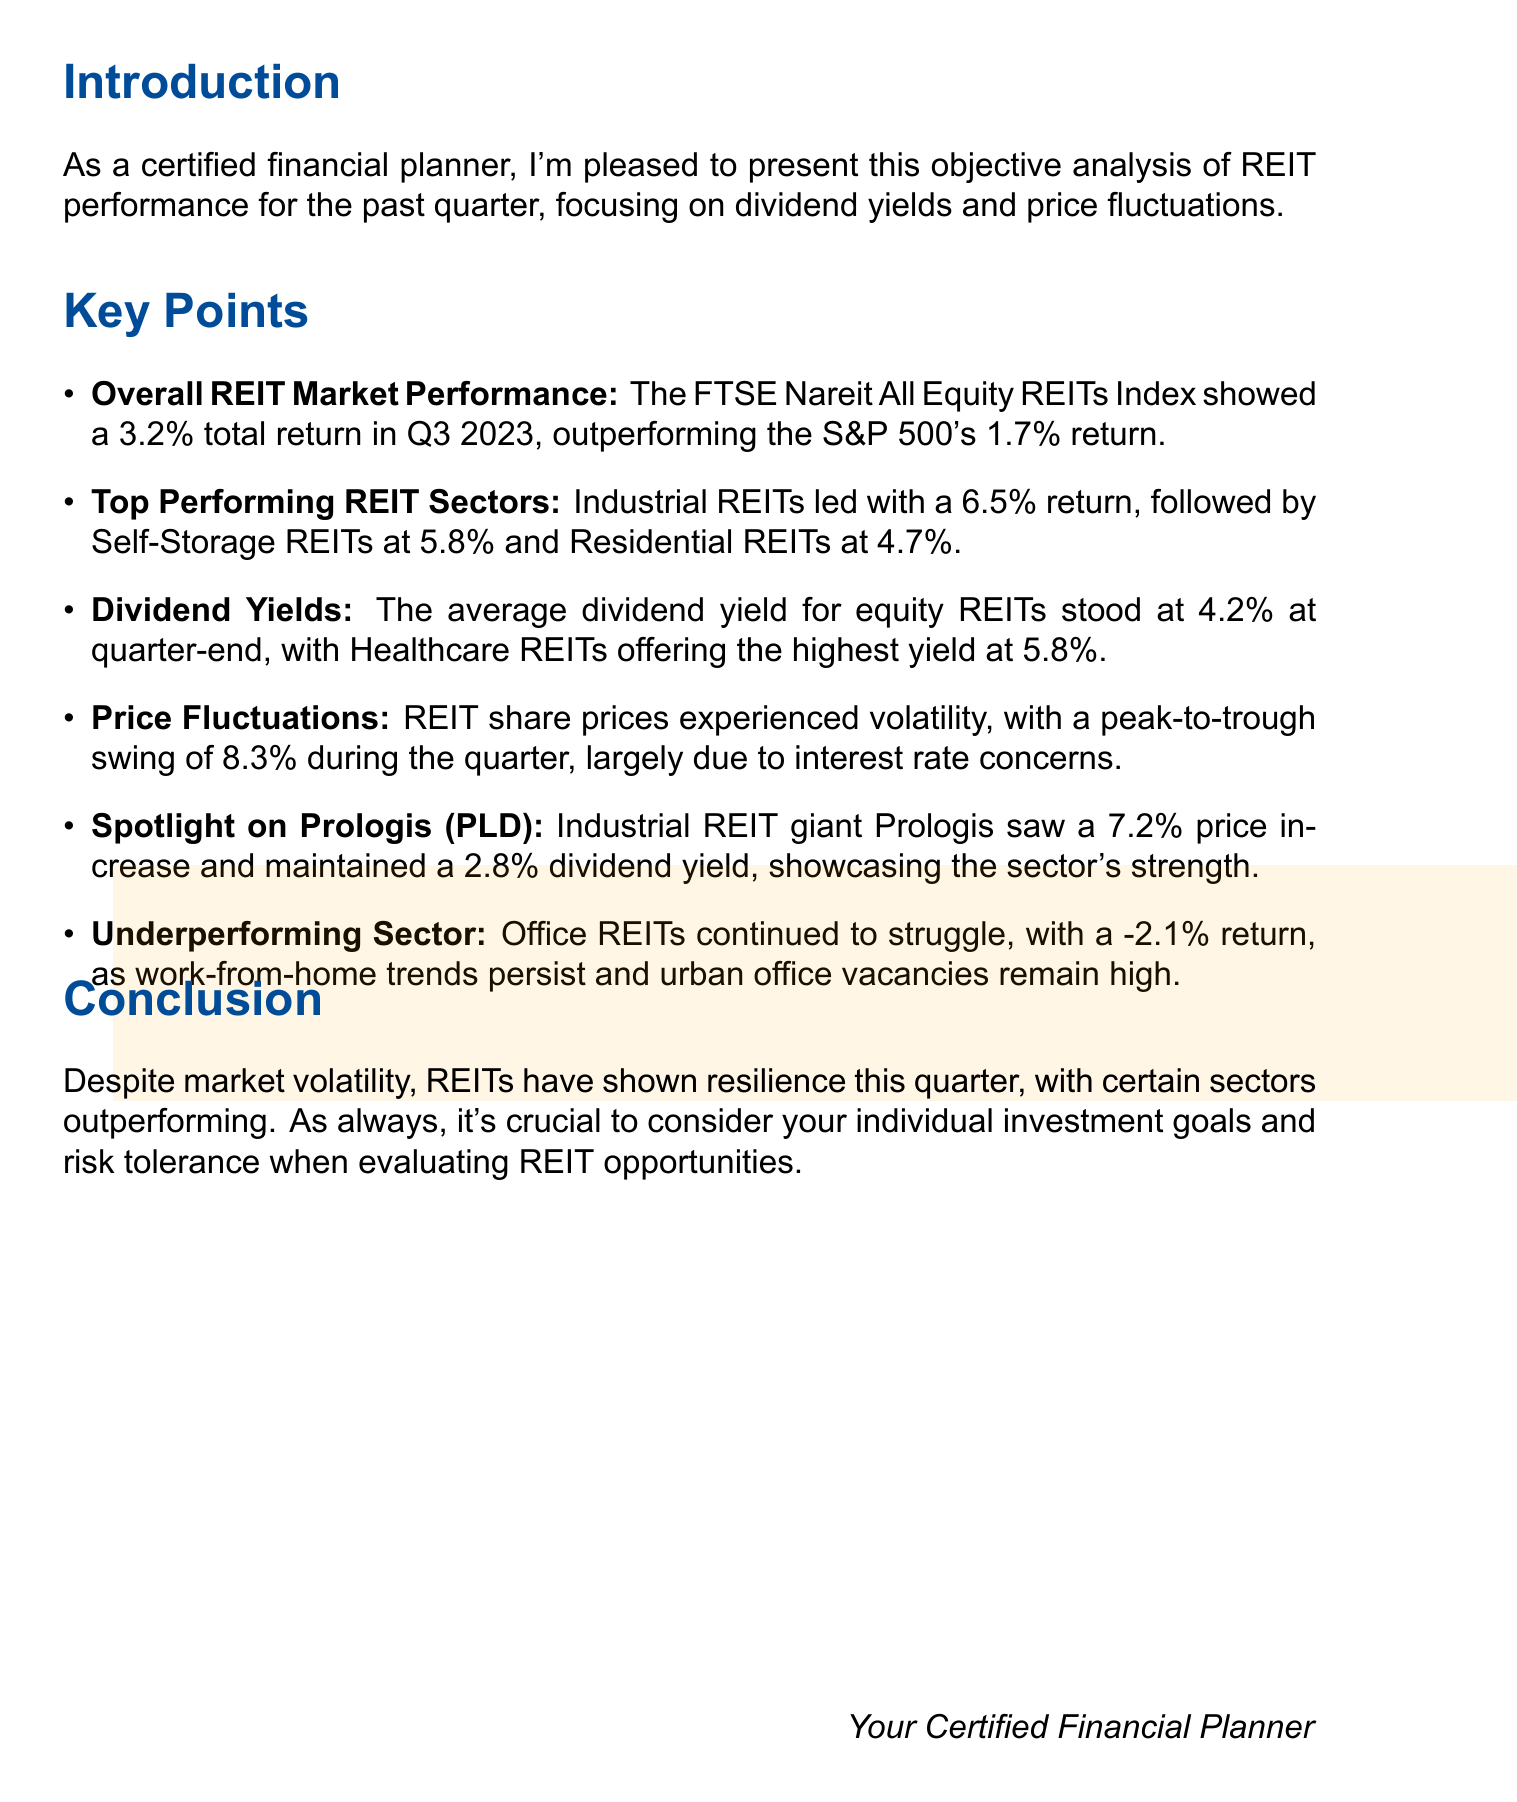What was the total return of the FTSE Nareit All Equity REITs Index in Q3 2023? The total return for the FTSE Nareit All Equity REITs Index in Q3 2023 was 3.2%.
Answer: 3.2% Which sector had the highest return in Q3 2023? The Industrial REITs sector led the performance with a return of 6.5%.
Answer: Industrial REITs What is the average dividend yield for equity REITs at quarter-end? The average dividend yield for equity REITs stood at 4.2% at quarter-end.
Answer: 4.2% What was the peak-to-trough price fluctuation for REITs during the quarter? The peak-to-trough price fluctuation for REITs was 8.3% during the quarter.
Answer: 8.3% What is the dividend yield of Prologis? Prologis maintained a dividend yield of 2.8%.
Answer: 2.8% What was the return of Office REITs in Q3 2023? The return of Office REITs in Q3 2023 was -2.1%.
Answer: -2.1% Which REIT sector provided the highest average dividend yield? Healthcare REITs offered the highest average dividend yield at 5.8%.
Answer: 5.8% What is emphasized in the conclusion regarding REIT investment considerations? The conclusion emphasizes considering individual investment goals and risk tolerance when evaluating REIT opportunities.
Answer: Individual investment goals and risk tolerance 